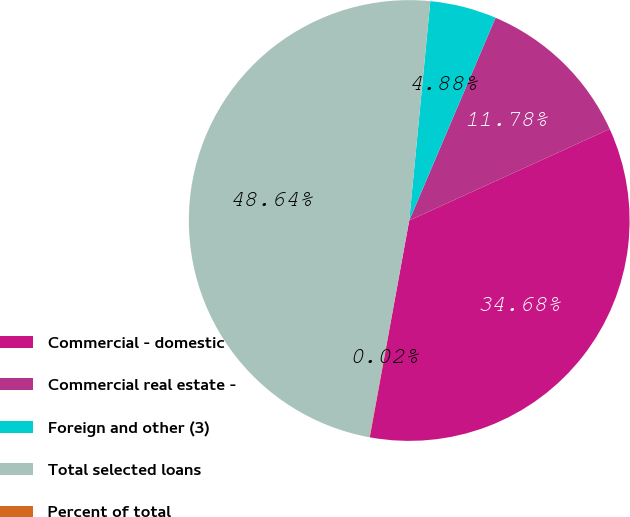Convert chart. <chart><loc_0><loc_0><loc_500><loc_500><pie_chart><fcel>Commercial - domestic<fcel>Commercial real estate -<fcel>Foreign and other (3)<fcel>Total selected loans<fcel>Percent of total<nl><fcel>34.68%<fcel>11.78%<fcel>4.88%<fcel>48.64%<fcel>0.02%<nl></chart> 